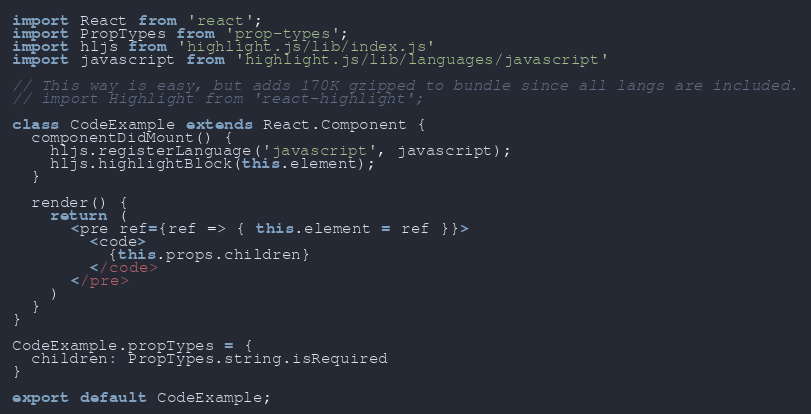<code> <loc_0><loc_0><loc_500><loc_500><_JavaScript_>import React from 'react';
import PropTypes from 'prop-types';
import hljs from 'highlight.js/lib/index.js'
import javascript from 'highlight.js/lib/languages/javascript'

// This way is easy, but adds 170K gzipped to bundle since all langs are included.
// import Highlight from 'react-highlight';

class CodeExample extends React.Component {
  componentDidMount() {
    hljs.registerLanguage('javascript', javascript);
    hljs.highlightBlock(this.element);
  }

  render() {
    return (
      <pre ref={ref => { this.element = ref }}>
        <code>
          {this.props.children}
        </code>
      </pre>
    )
  }
}

CodeExample.propTypes = {
  children: PropTypes.string.isRequired
}

export default CodeExample;</code> 